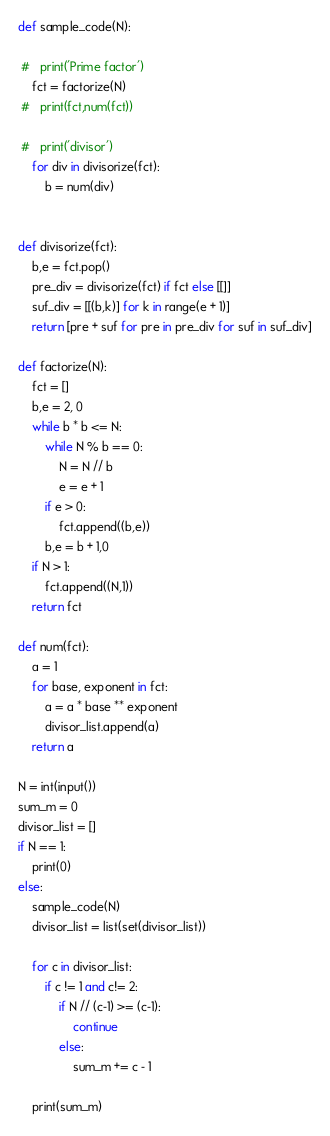Convert code to text. <code><loc_0><loc_0><loc_500><loc_500><_Python_>def sample_code(N):

 #   print('Prime factor')
    fct = factorize(N)
 #   print(fct,num(fct))

 #   print('divisor')
    for div in divisorize(fct):
        b = num(div)


def divisorize(fct):
    b,e = fct.pop()
    pre_div = divisorize(fct) if fct else [[]]
    suf_div = [[(b,k)] for k in range(e + 1)]
    return [pre + suf for pre in pre_div for suf in suf_div]

def factorize(N):
    fct = []
    b,e = 2, 0
    while b * b <= N:
        while N % b == 0:
            N = N // b
            e = e + 1
        if e > 0:
            fct.append((b,e))
        b,e = b + 1,0
    if N > 1:
        fct.append((N,1))
    return fct

def num(fct):
    a = 1
    for base, exponent in fct:
        a = a * base ** exponent
        divisor_list.append(a)
    return a

N = int(input())
sum_m = 0
divisor_list = []
if N == 1:
    print(0)
else:
    sample_code(N)
    divisor_list = list(set(divisor_list))

    for c in divisor_list:
        if c != 1 and c!= 2:
            if N // (c-1) >= (c-1):
                continue
            else:
                sum_m += c - 1

    print(sum_m)</code> 